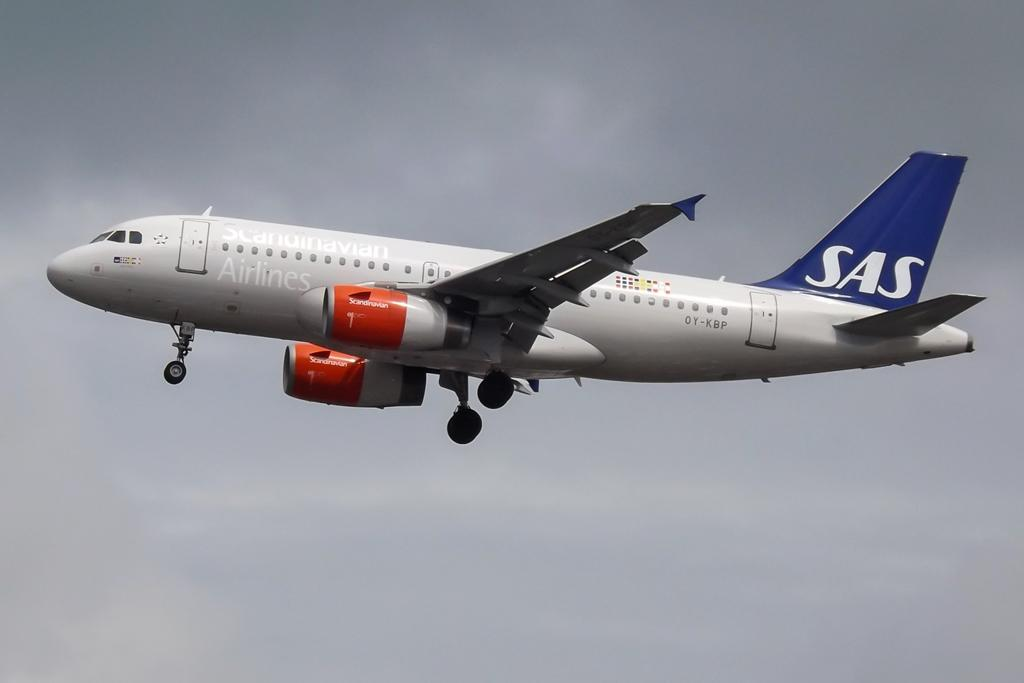<image>
Summarize the visual content of the image. An SAS airplane from Scandinavian Airlines flies through the sky. 